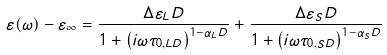Convert formula to latex. <formula><loc_0><loc_0><loc_500><loc_500>\varepsilon ( \omega ) - \varepsilon _ { \infty } = \frac { \Delta \varepsilon _ { L } D } { 1 + \left ( i \omega \tau _ { 0 , L D } \right ) ^ { 1 - \alpha _ { L } D } } + \frac { \Delta \varepsilon _ { S } D } { 1 + \left ( i \omega \tau _ { 0 , S D } \right ) ^ { 1 - \alpha _ { S } D } }</formula> 